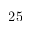<formula> <loc_0><loc_0><loc_500><loc_500>2 5</formula> 